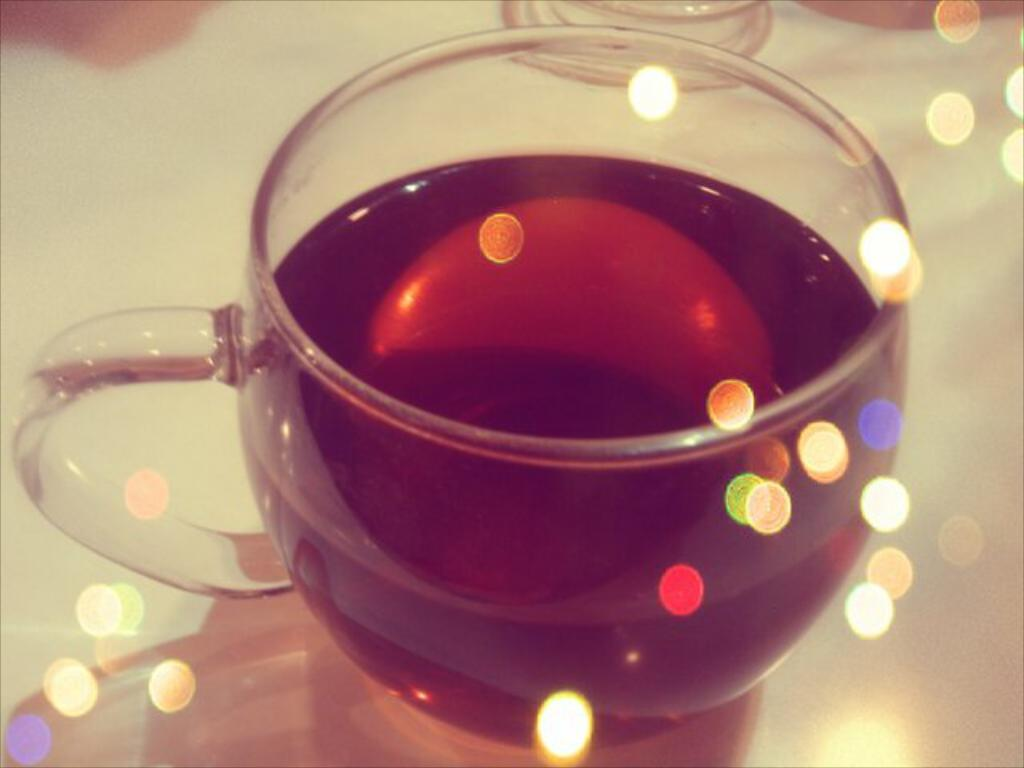How has the image been altered or modified? The image is edited. What is present in the image besides the edited elements? There is a cup of tea in the image. What can be seen as a result of the cup's presence on a surface? The reflection of the cup is visible on a glass table. What type of star can be seen in the image? There is no star present in the image. How is the distribution of tea in the cup affected by the editing process? The editing process does not affect the distribution of tea in the cup; it is only visible in the image. 